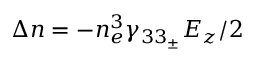<formula> <loc_0><loc_0><loc_500><loc_500>\Delta n = - n _ { e } ^ { 3 } { { \gamma } _ { 3 3 _ { \pm } } } { { E } _ { z } } / 2</formula> 